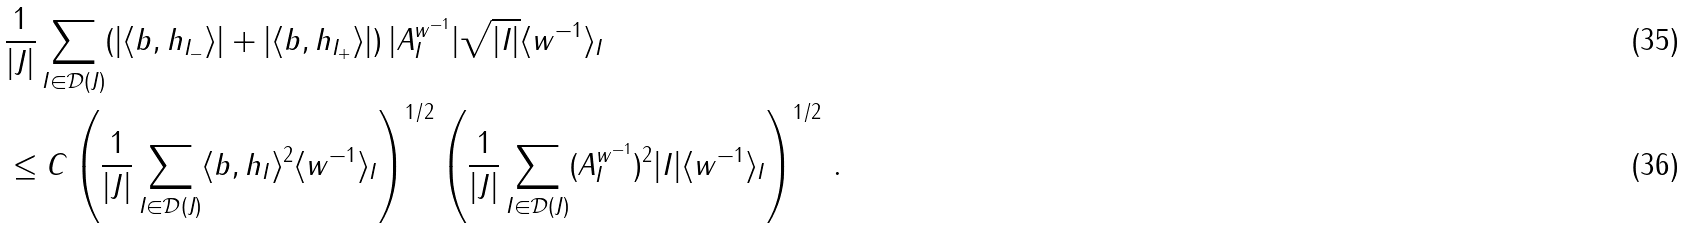Convert formula to latex. <formula><loc_0><loc_0><loc_500><loc_500>& \frac { 1 } { | J | } \sum _ { I \in \mathcal { D } ( J ) } ( | \langle b , h _ { I _ { - } } \rangle | + | \langle b , h _ { I _ { + } } \rangle | ) \, | A _ { I } ^ { w ^ { - 1 } } | \sqrt { | I | } \langle w ^ { - 1 } \rangle _ { I } \\ & \leq C \left ( \frac { 1 } { | J | } \sum _ { I \in \mathcal { D } ( J ) } \langle b , h _ { I } \rangle ^ { 2 } \langle w ^ { - 1 } \rangle _ { I } \right ) ^ { 1 / 2 } \left ( \frac { 1 } { | J | } \sum _ { I \in \mathcal { D } ( J ) } ( A ^ { w ^ { - 1 } } _ { I } ) ^ { 2 } | I | \langle w ^ { - 1 } \rangle _ { I } \right ) ^ { 1 / 2 } \, .</formula> 